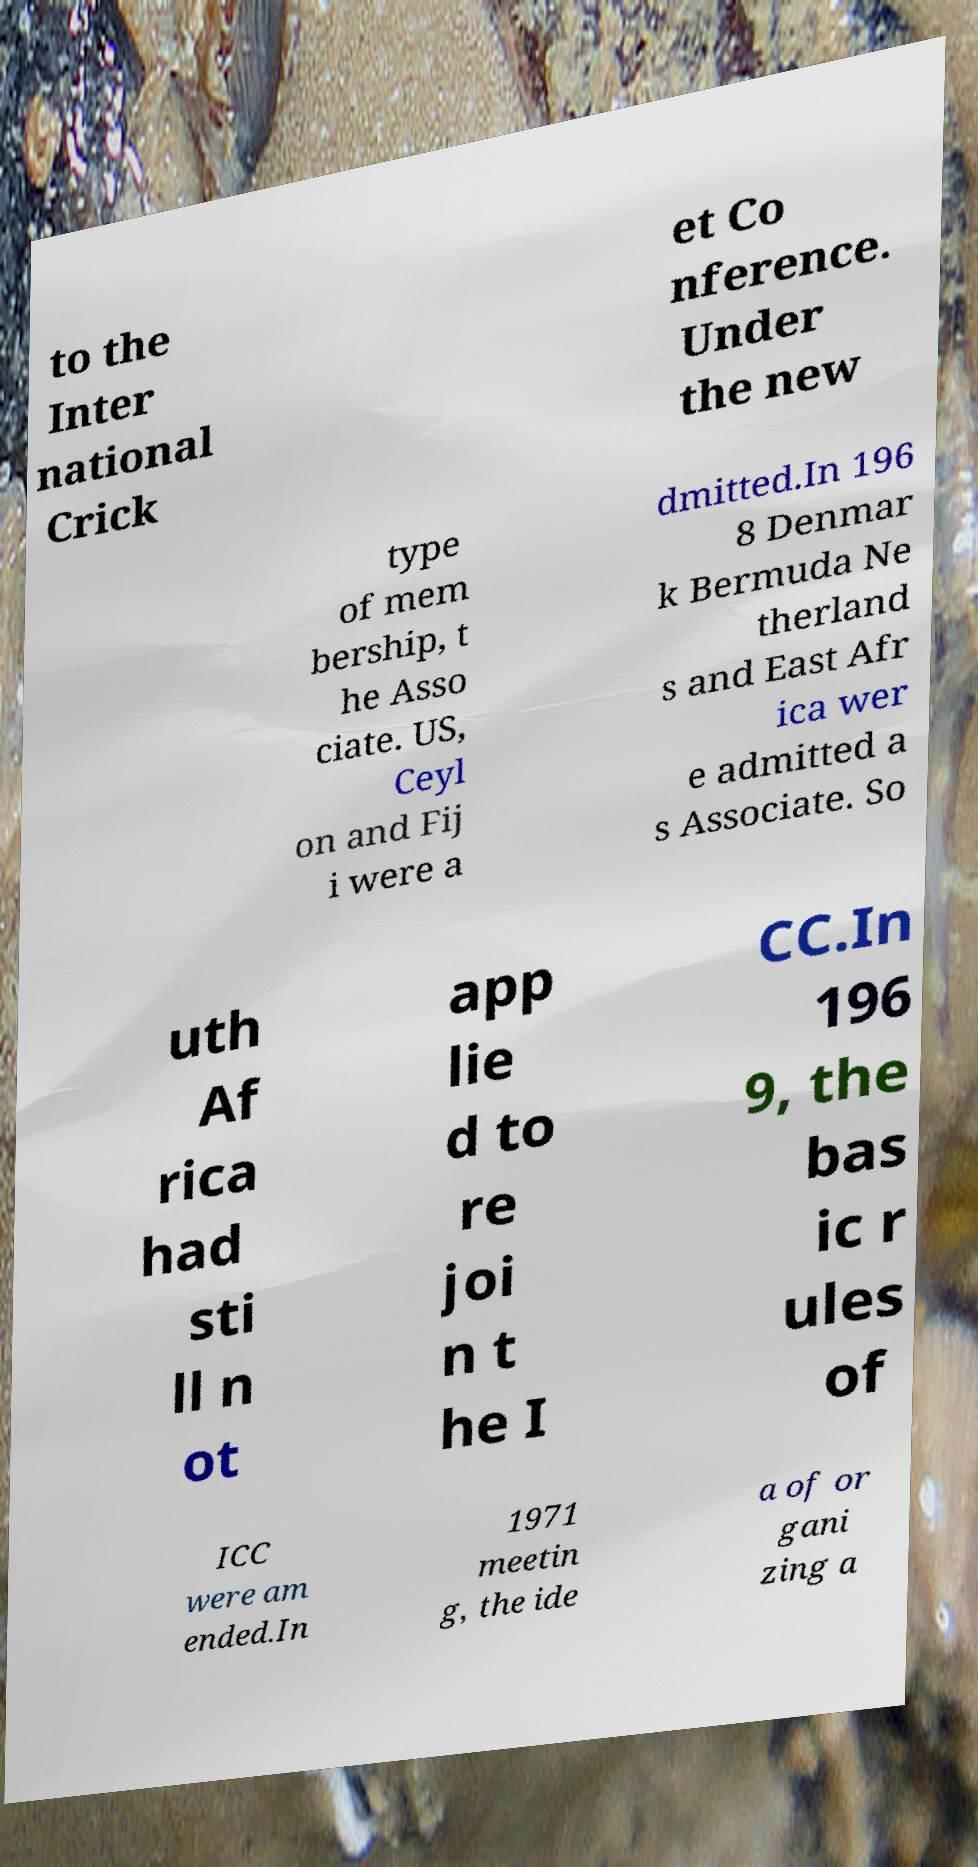Please read and relay the text visible in this image. What does it say? to the Inter national Crick et Co nference. Under the new type of mem bership, t he Asso ciate. US, Ceyl on and Fij i were a dmitted.In 196 8 Denmar k Bermuda Ne therland s and East Afr ica wer e admitted a s Associate. So uth Af rica had sti ll n ot app lie d to re joi n t he I CC.In 196 9, the bas ic r ules of ICC were am ended.In 1971 meetin g, the ide a of or gani zing a 